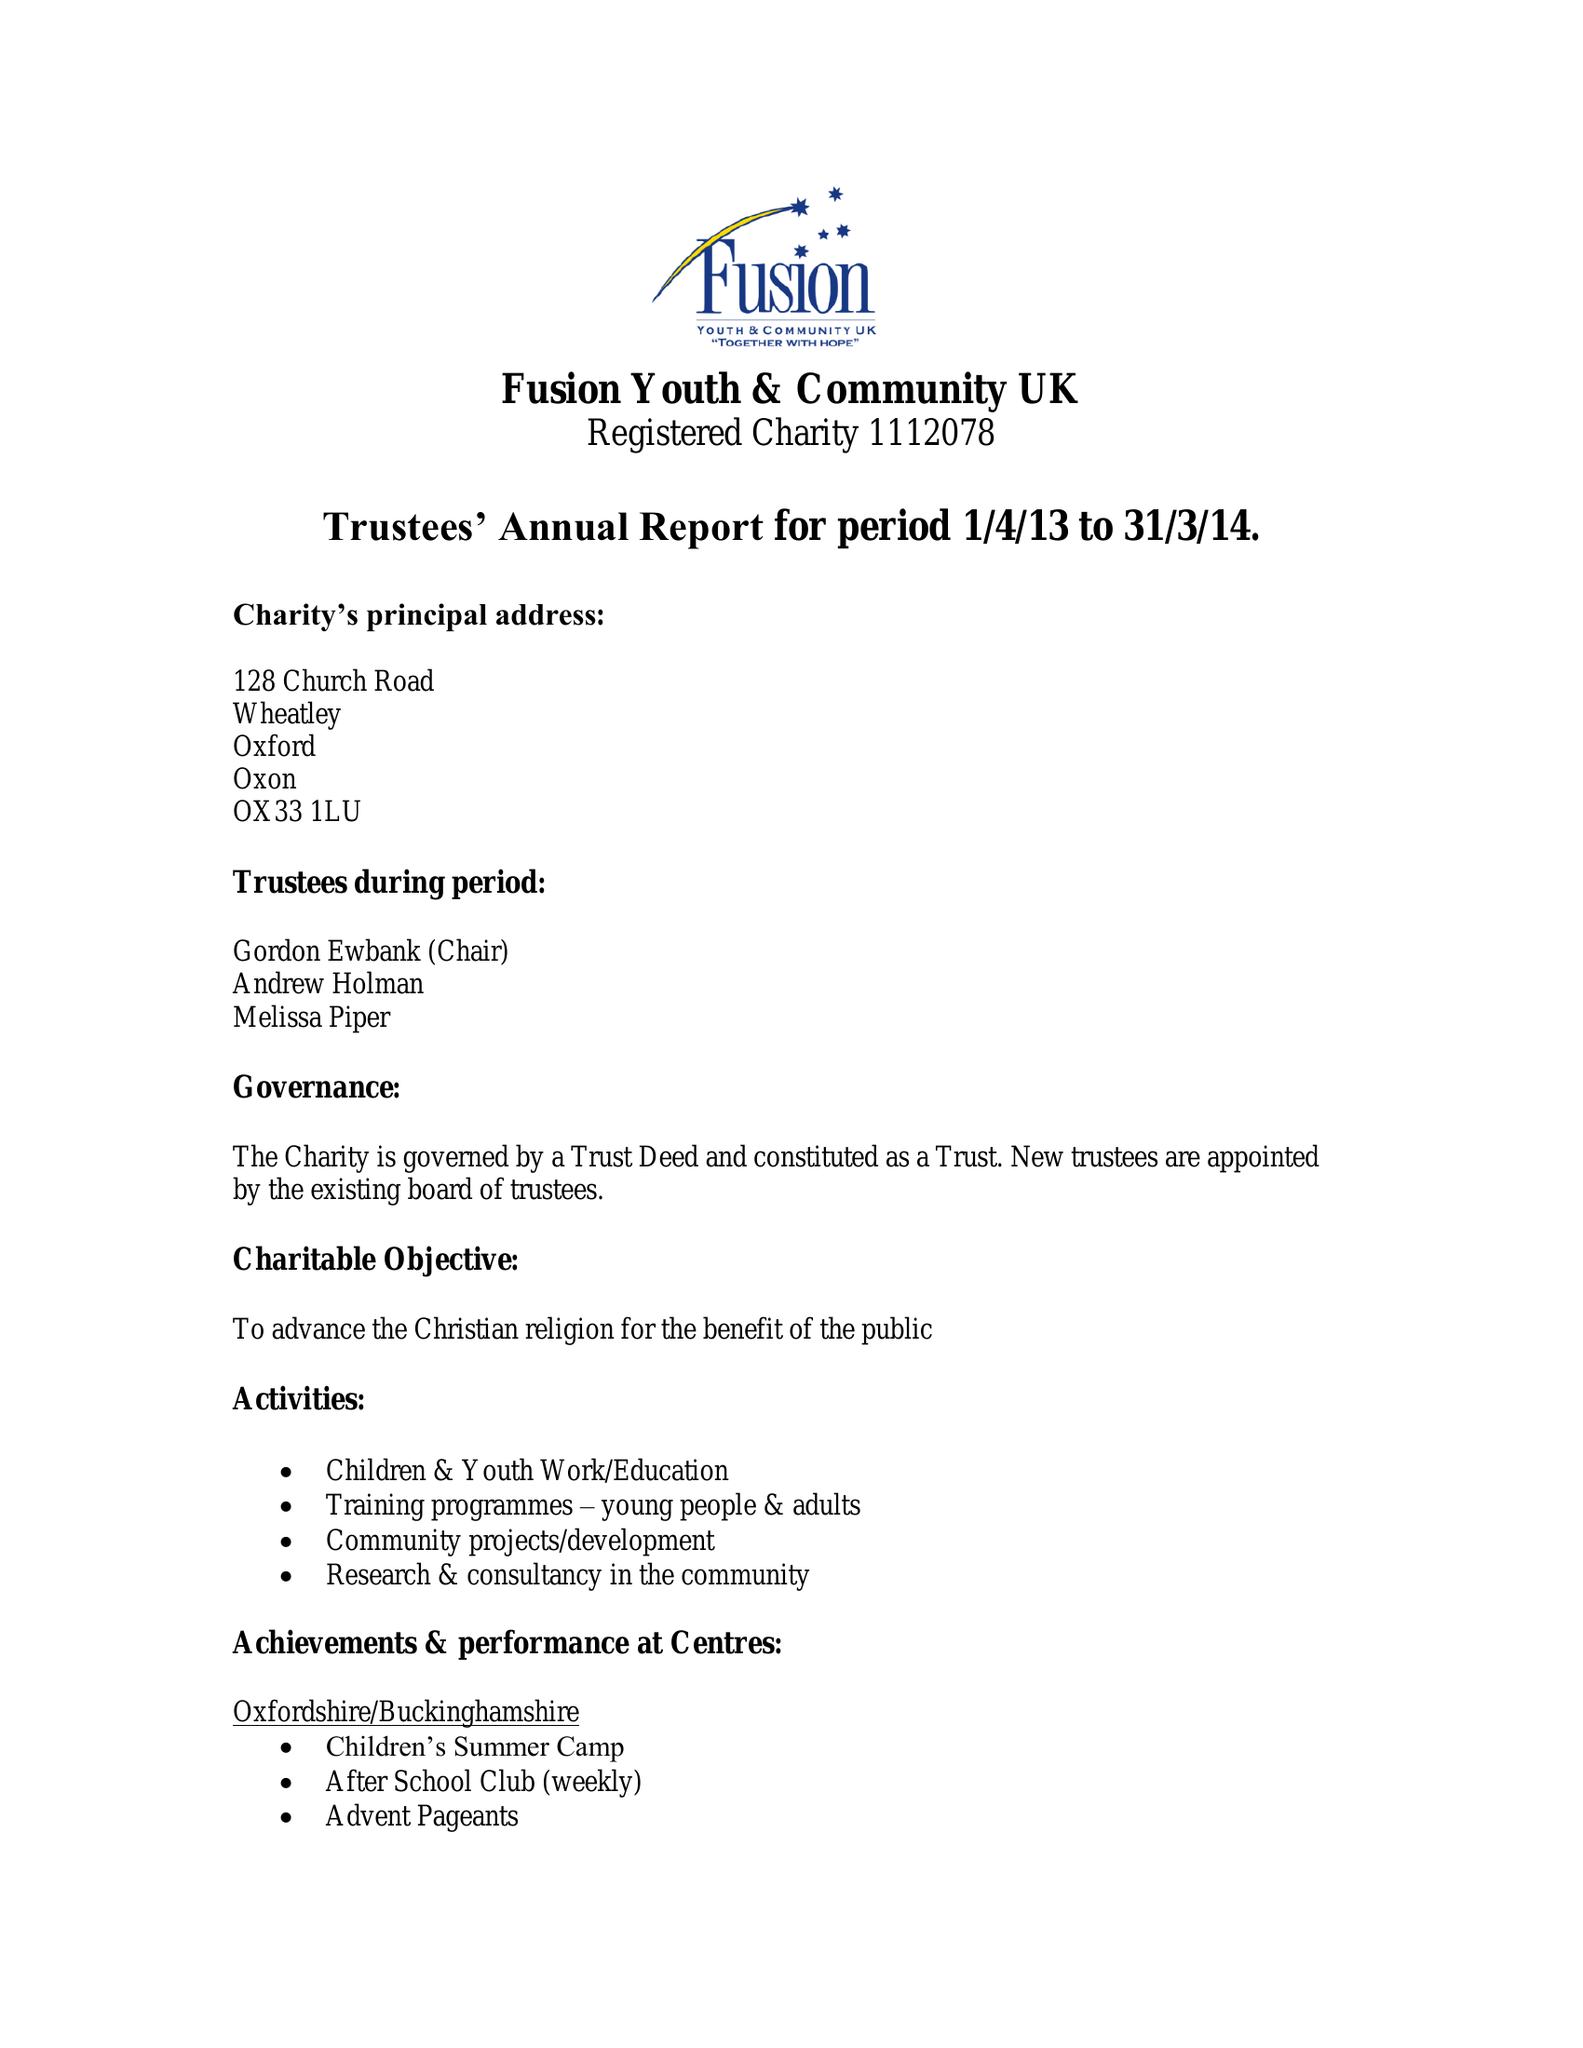What is the value for the income_annually_in_british_pounds?
Answer the question using a single word or phrase. 84718.00 